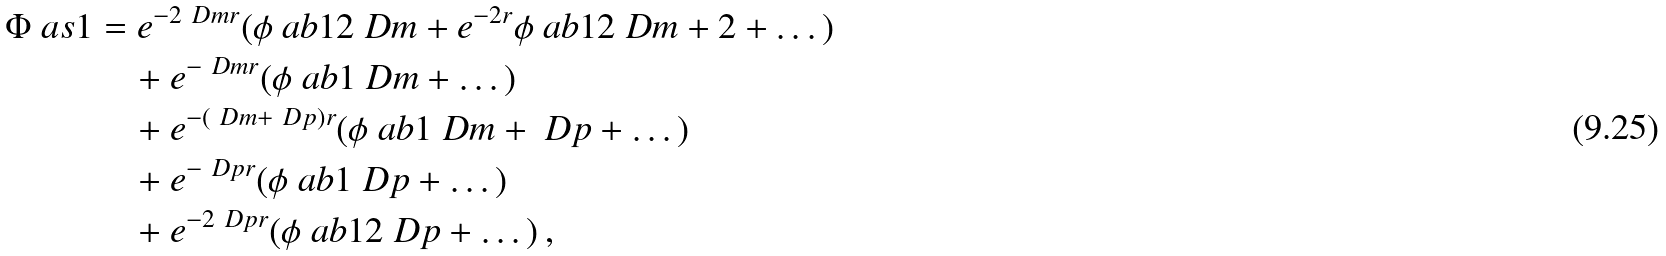<formula> <loc_0><loc_0><loc_500><loc_500>\Phi \ a s { 1 } & = e ^ { - 2 \ D m r } ( \phi \ a b { 1 } { 2 \ D m } + e ^ { - 2 r } \phi \ a b { 1 } { 2 \ D m + 2 } + \dots ) \\ & \quad + e ^ { - \ D m r } ( \phi \ a b { 1 } { \ D m } + \dots ) \\ & \quad + e ^ { - ( \ D m + \ D p ) r } ( \phi \ a b { 1 } { \ D m + \ D p } + \dots ) \\ & \quad + e ^ { - \ D p r } ( \phi \ a b { 1 } { \ D p } + \dots ) \\ & \quad + e ^ { - 2 \ D p r } ( \phi \ a b { 1 } { 2 \ D p } + \dots ) \, ,</formula> 